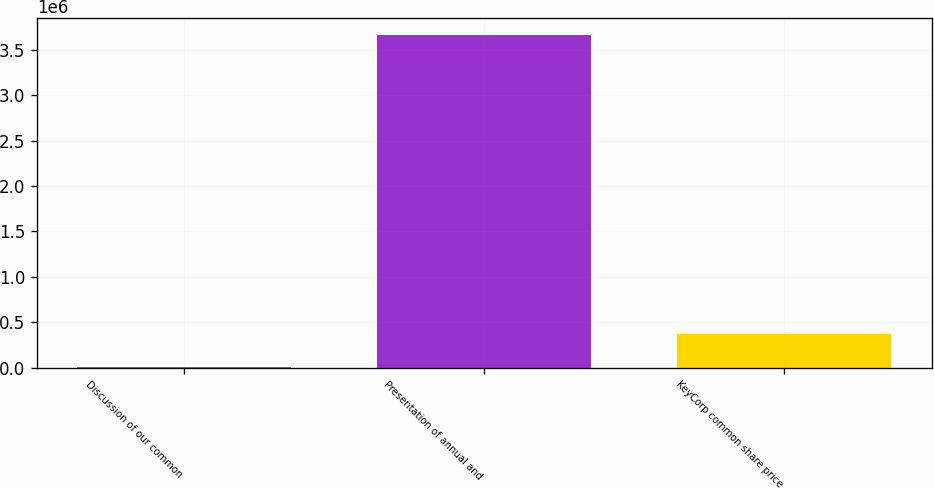Convert chart to OTSL. <chart><loc_0><loc_0><loc_500><loc_500><bar_chart><fcel>Discussion of our common<fcel>Presentation of annual and<fcel>KeyCorp common share price<nl><fcel>71<fcel>3.6711e+06<fcel>367174<nl></chart> 